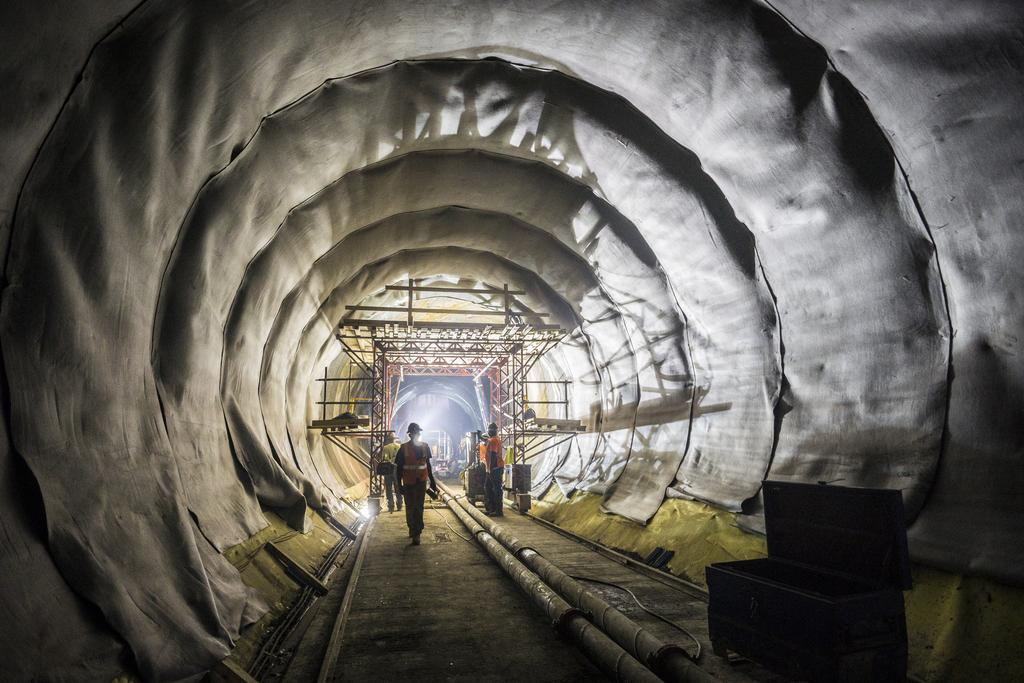Who or what is present in the image? There are people in the image. What type of objects can be seen in the image? There are pipes and a box on the ground in the image. What can be seen in the background of the image? In the background, there are rods visible, as well as clothes and other objects. What type of ghost is visible in the image? There is no ghost present in the image. What kind of band is playing in the background of the image? There is no band present in the image. 